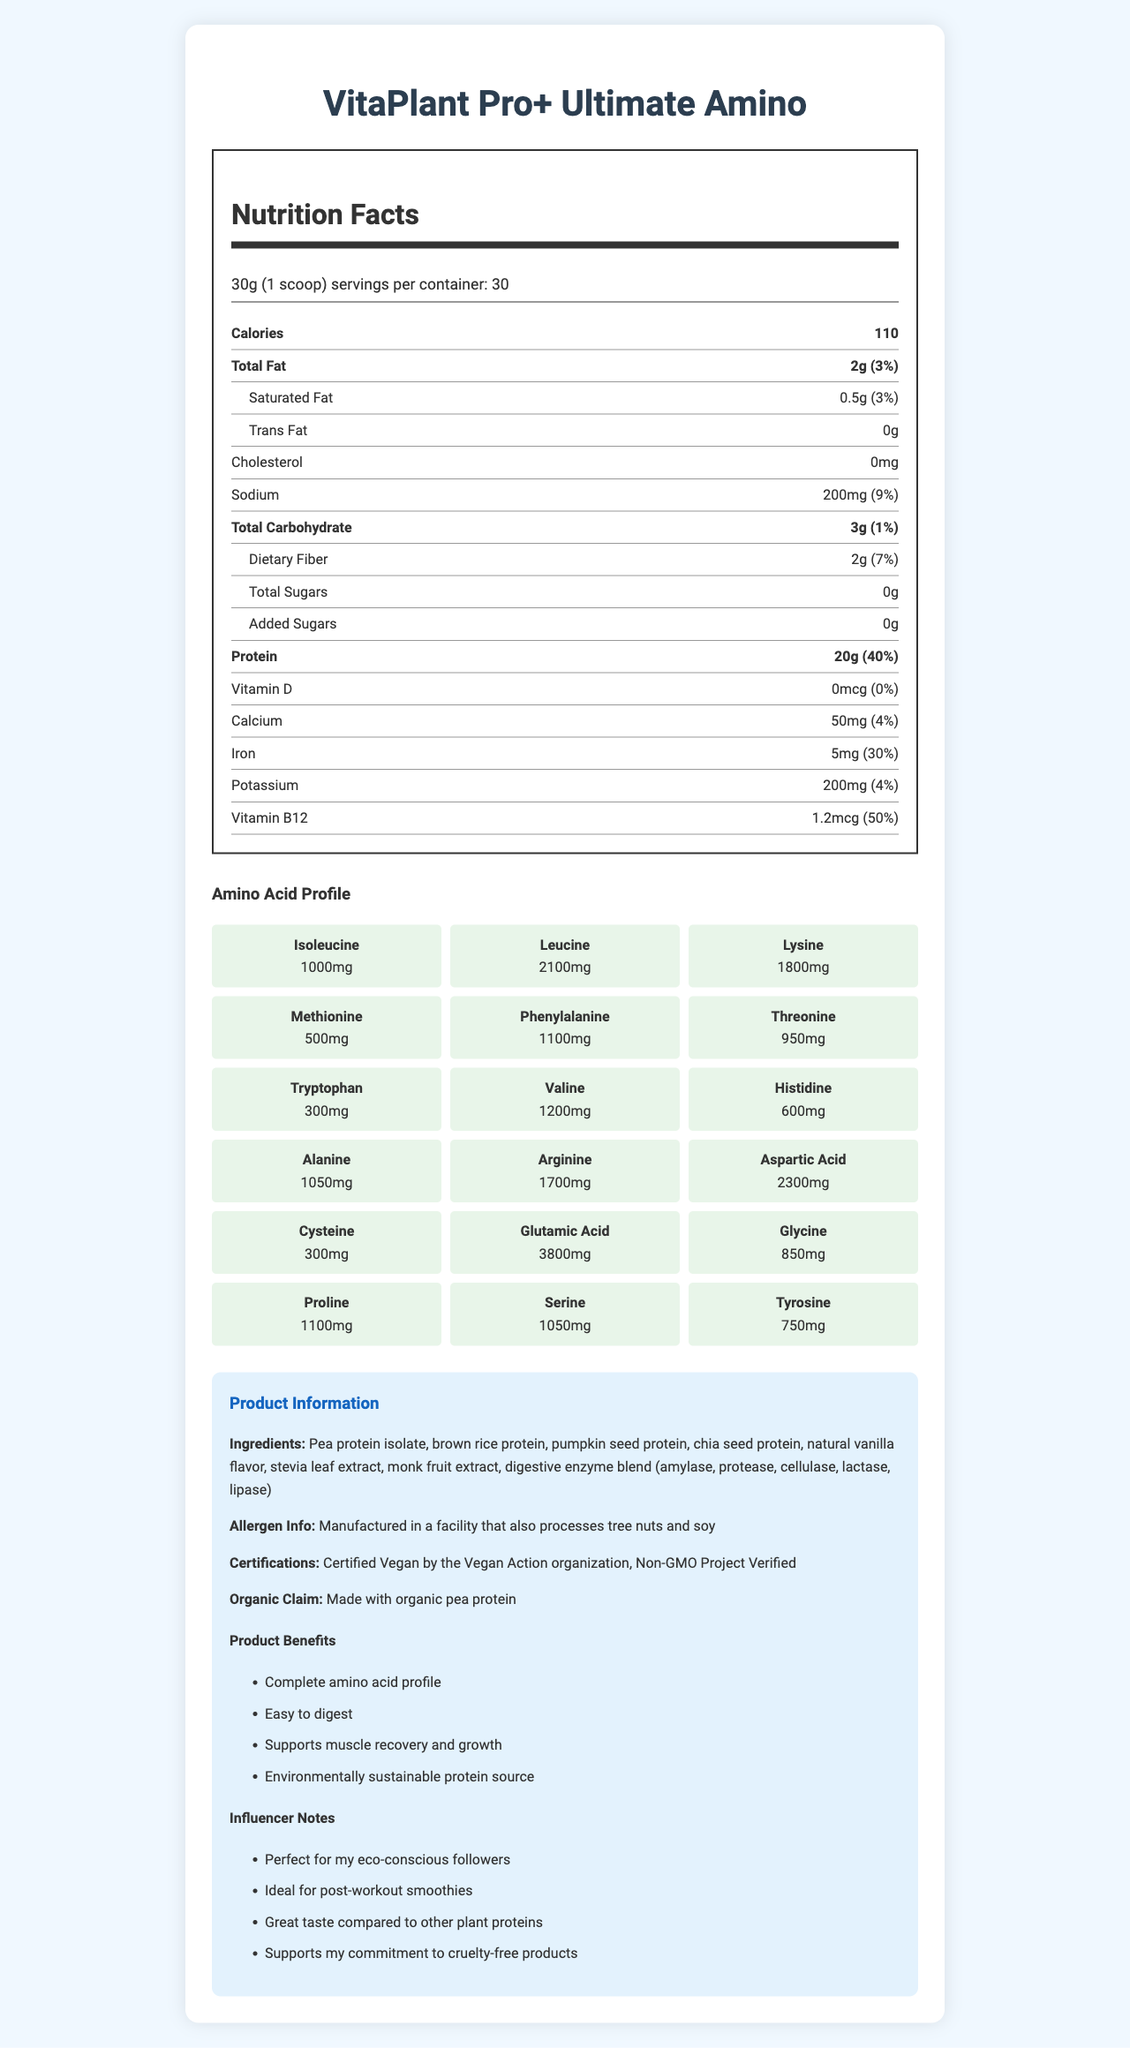what is the serving size of VitaPlant Pro+ Ultimate Amino? The document lists the serving size as 30g (1 scoop).
Answer: 30g (1 scoop) how many calories are in one serving? The document states that there are 110 calories per serving.
Answer: 110 calories what is the daily value percentage of iron for one serving? The nutrient section of the document indicates the daily value percentage of iron is 30%.
Answer: 30% list one allergen mentioned in the allergen information. The allergen info section of the document mentions that the product is manufactured in a facility that processes tree nuts and soy.
Answer: tree nuts what is the amount of protein per serving? The protein section of the nutrition label states that there are 20g of protein per serving.
Answer: 20g what are the main benefits of this plant-based protein powder? These benefits are listed under the "Product Benefits" section.
Answer: Complete amino acid profile, Easy to digest, Supports muscle recovery and growth, Environmentally sustainable protein source which ingredient provides a natural sweetener in VitaPlant Pro+ Ultimate Amino? A. Pea protein isolate B. Brown rice protein C. Stevia leaf extract D. Pumpkin seed protein The ingredients list shows that Stevia leaf extract is used as a natural sweetener.
Answer: C what is the daily value percentage of calcium provided by one serving? The nutrient section indicates that one serving provides 4% of the daily value of calcium.
Answer: 4% is VitaPlant Pro+ Ultimate Amino certified vegan? The document states that the product is "Certified Vegan by the Vegan Action organization."
Answer: Yes which amino acid has the highest content in the amino acid profile? A. Isoleucine B. Leucine C. Glutamic Acid D. Aspartic Acid The amino acid profile indicates that Glutamic Acid has the highest content with 3800mg.
Answer: C how many servings are there per container? The document states that there are 30 servings per container.
Answer: 30 servings does the VitaPlant Pro+ Ultimate Amino contain any added sugars? The nutrition label indicates that there are 0g of added sugars.
Answer: No what is the main idea of the document? The main idea of the document is to present the nutritional facts and benefits of the plant-based protein powder, VitaPlant Pro+ Ultimate Amino, with a focus on its comprehensive amino acid profile, certifications, and recipient suitability for eco-conscious and health-oriented individuals.
Answer: The document provides detailed nutritional information for VitaPlant Pro+ Ultimate Amino, highlighting its complete amino acid profile, nutritional content, and benefits. It also includes ingredient and allergen information along with influencer notes. what are the flavoring agents used in this protein powder? The ingredients list contains these items as flavoring agents.
Answer: Natural vanilla flavor, stevia leaf extract, monk fruit extract is the protein powder made with organic ingredients? The document states that the product is made with organic pea protein.
Answer: Yes what is the daily value percentage of dietary fiber in one serving? The dietary fiber section of the nutrition label indicates that each serving provides 7% of the daily value of dietary fiber.
Answer: 7% what is the amount of sodium per serving? The sodium section in the nutrition label shows that each serving contains 200mg of sodium.
Answer: 200mg can the digestive enzyme blend in the product help with digestion? While the document lists the digestive enzyme blend (amylase, protease, cellulase, lactase, lipase), it doesn't explicitly state how effective it is in aiding digestion.
Answer: Cannot be determined how much B12 vitamin is there per serving? The document indicates that each serving contains 1.2mcg of Vitamin B12, which is 50% of the daily value.
Answer: 1.2mcg 